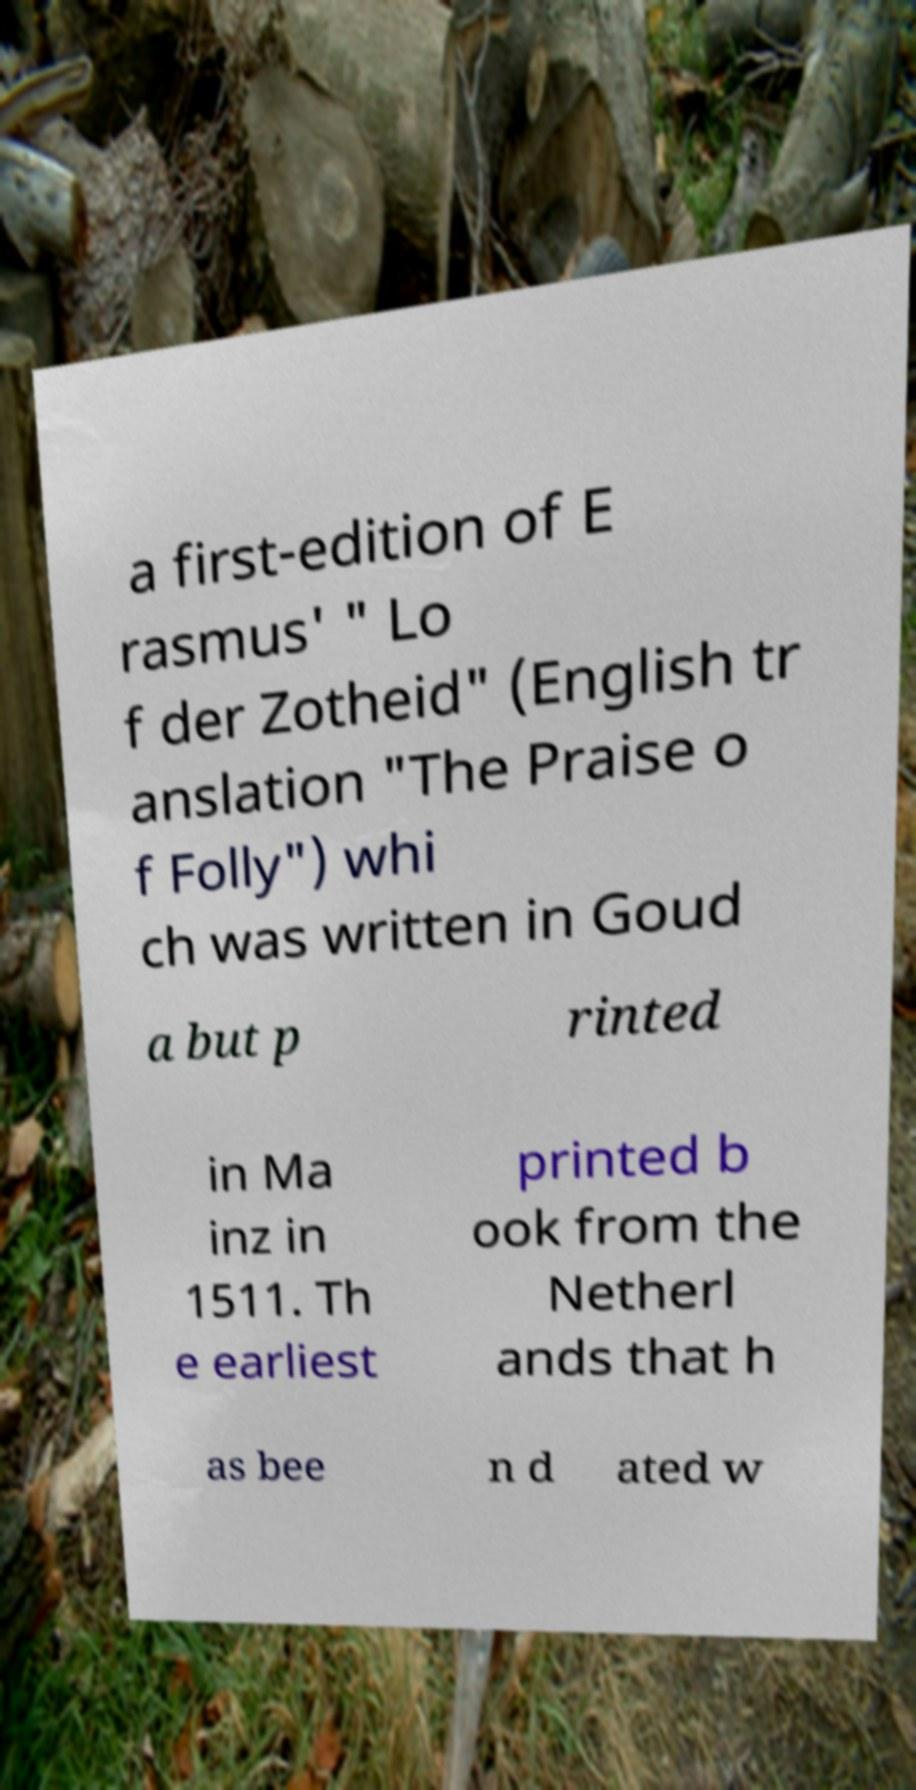Can you read and provide the text displayed in the image?This photo seems to have some interesting text. Can you extract and type it out for me? a first-edition of E rasmus' " Lo f der Zotheid" (English tr anslation "The Praise o f Folly") whi ch was written in Goud a but p rinted in Ma inz in 1511. Th e earliest printed b ook from the Netherl ands that h as bee n d ated w 